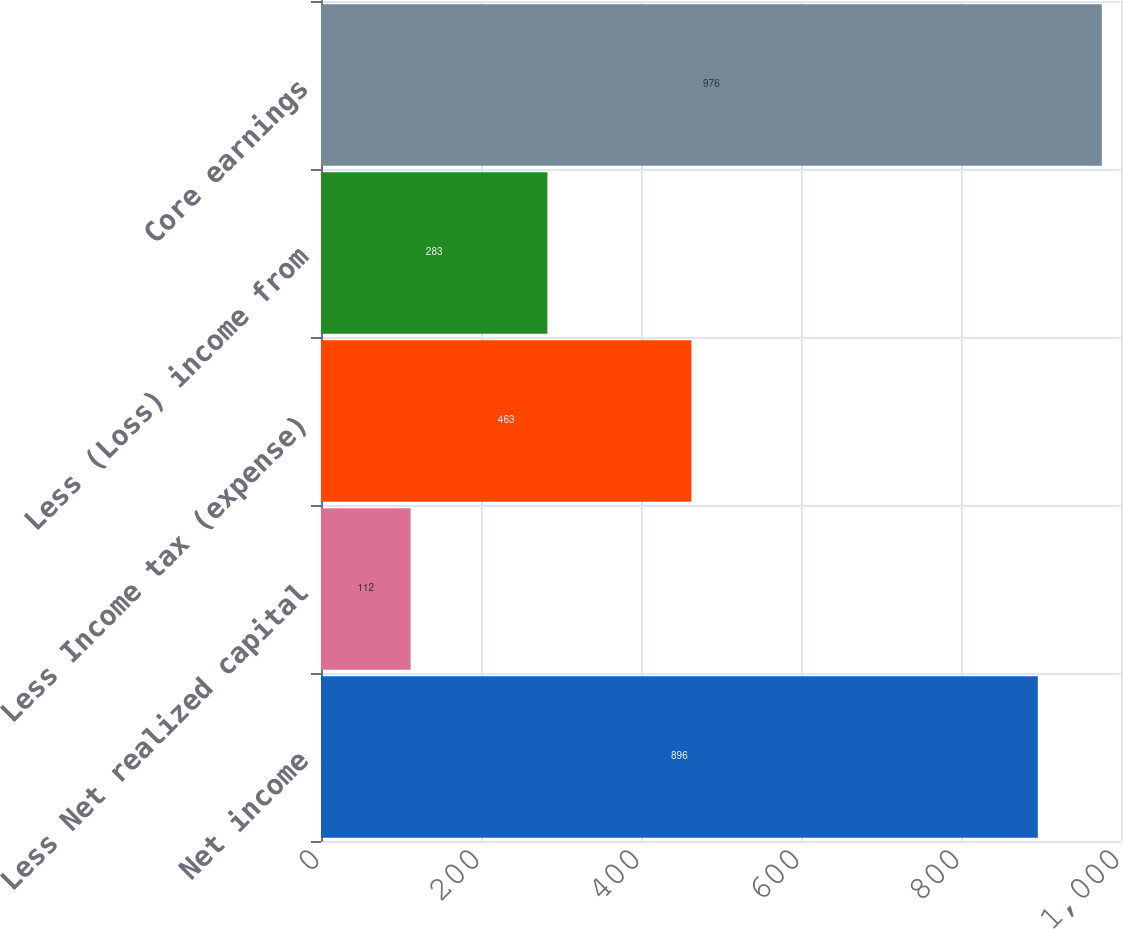Convert chart to OTSL. <chart><loc_0><loc_0><loc_500><loc_500><bar_chart><fcel>Net income<fcel>Less Net realized capital<fcel>Less Income tax (expense)<fcel>Less (Loss) income from<fcel>Core earnings<nl><fcel>896<fcel>112<fcel>463<fcel>283<fcel>976<nl></chart> 